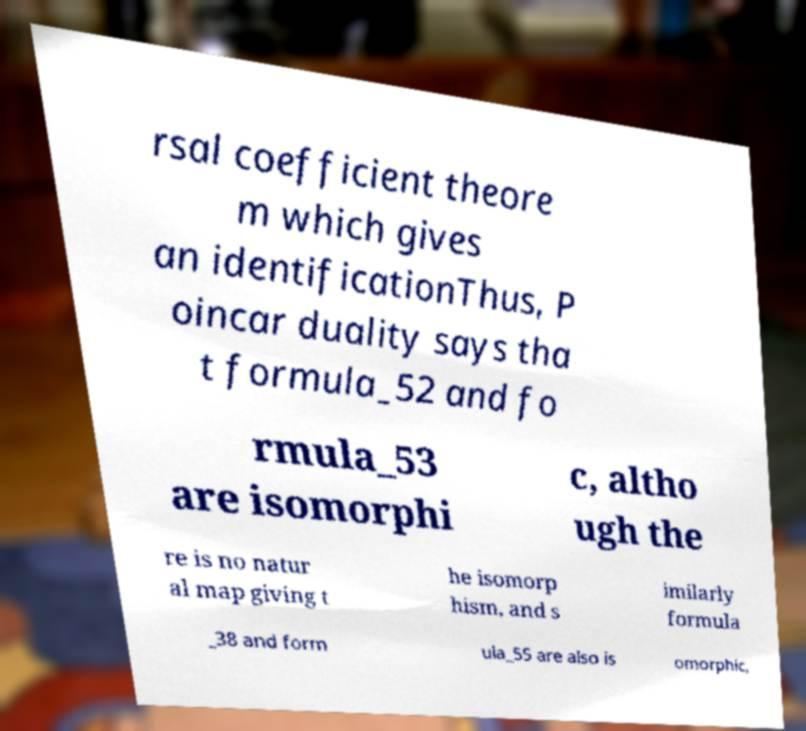For documentation purposes, I need the text within this image transcribed. Could you provide that? rsal coefficient theore m which gives an identificationThus, P oincar duality says tha t formula_52 and fo rmula_53 are isomorphi c, altho ugh the re is no natur al map giving t he isomorp hism, and s imilarly formula _38 and form ula_55 are also is omorphic, 